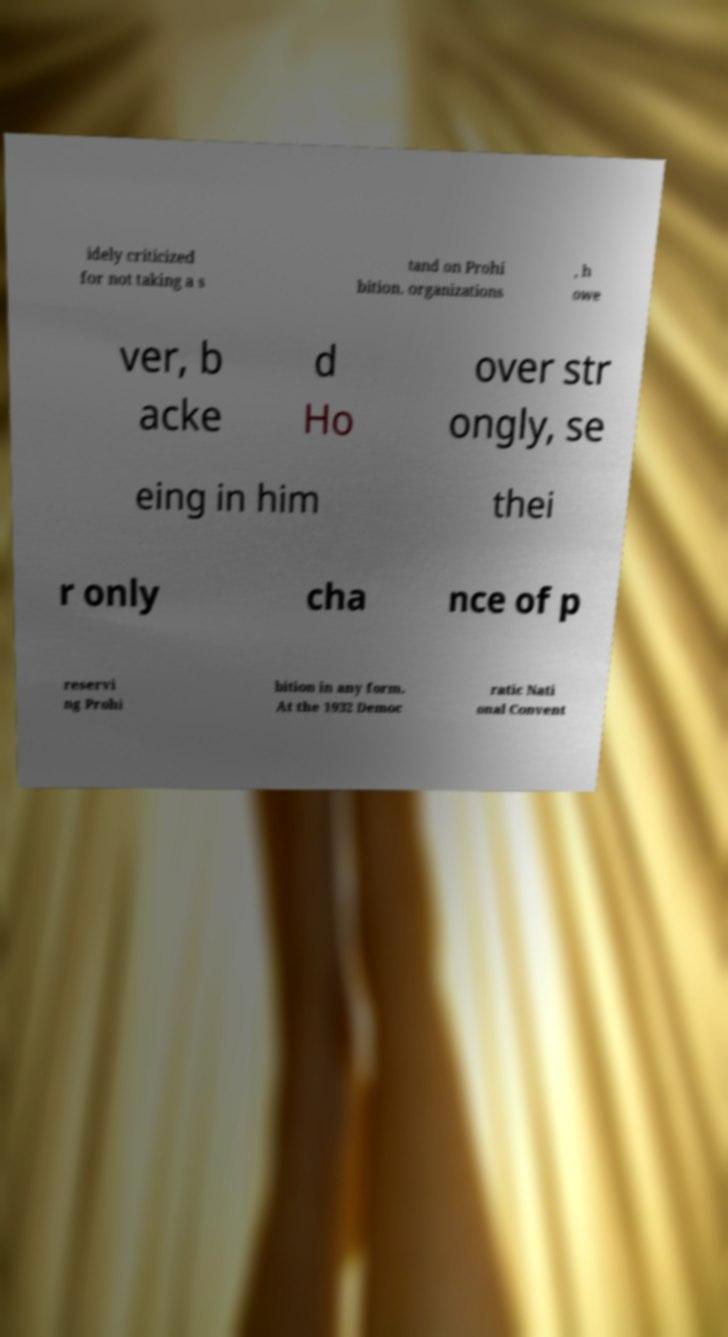Could you extract and type out the text from this image? idely criticized for not taking a s tand on Prohi bition. organizations , h owe ver, b acke d Ho over str ongly, se eing in him thei r only cha nce of p reservi ng Prohi bition in any form. At the 1932 Democ ratic Nati onal Convent 